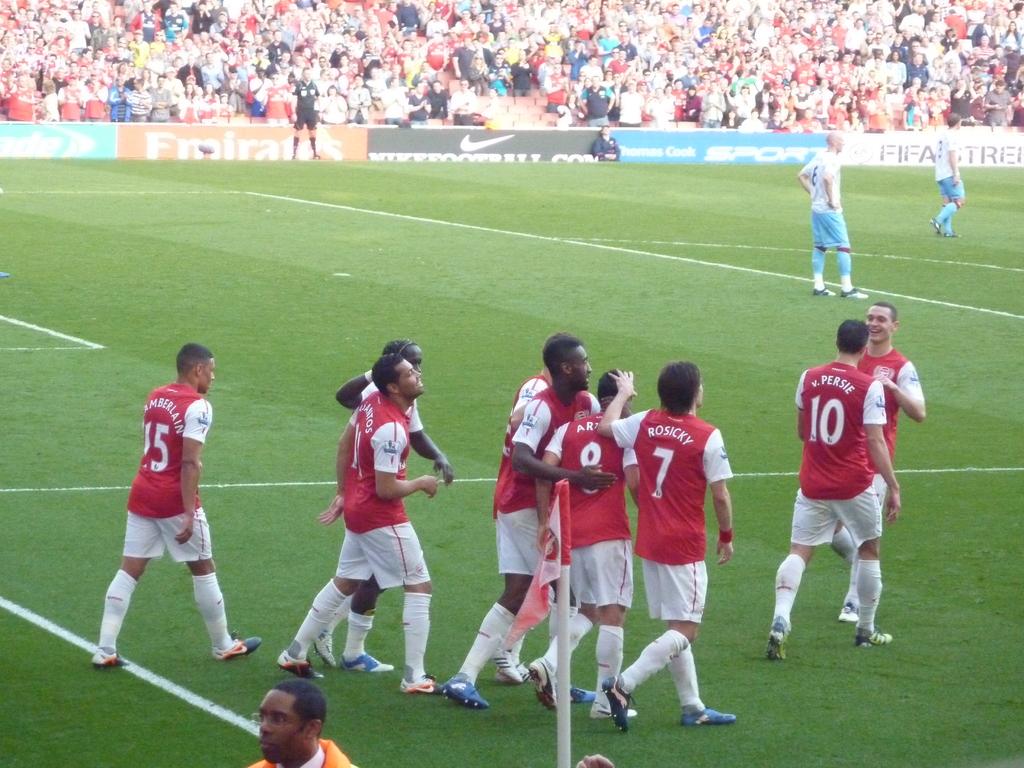What number is the leftmost red player?
Make the answer very short. 15. What shoe company is being advertised?
Your response must be concise. Nike. 